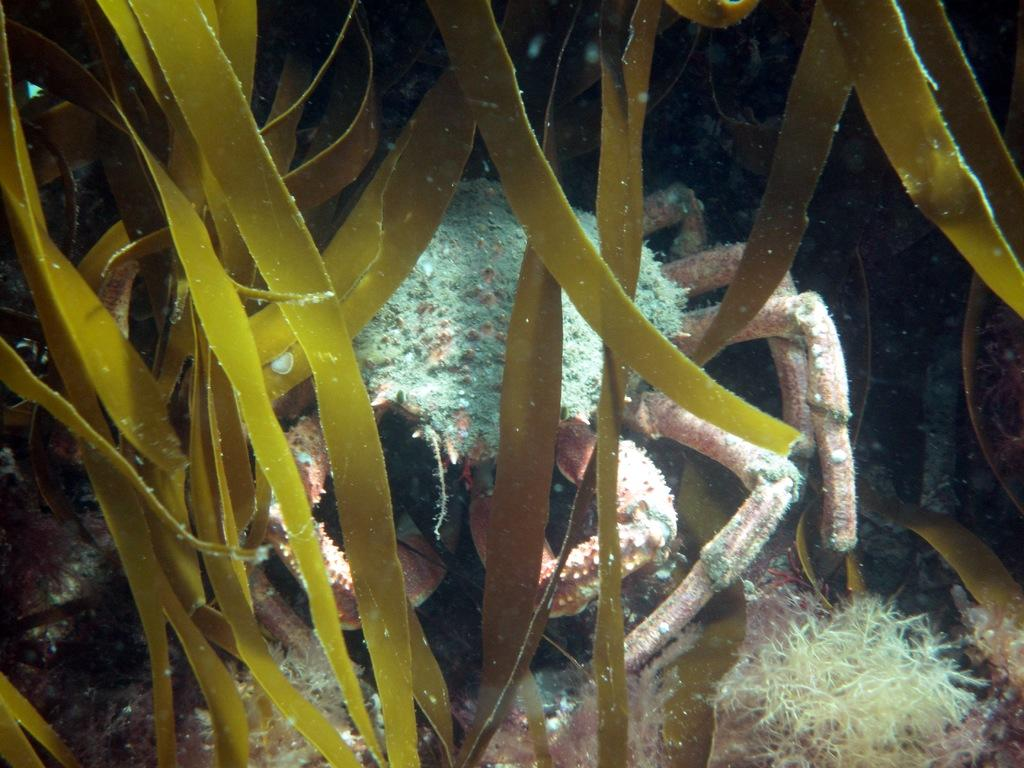What animal is present in the image? There is a crab in the image. Where is the crab located? The crab is underwater in the image. What else can be seen underwater in the image? There are plants underwater in the image. What type of office supplies can be seen in the image? There are no office supplies present in the image; it features a crab underwater with plants. 